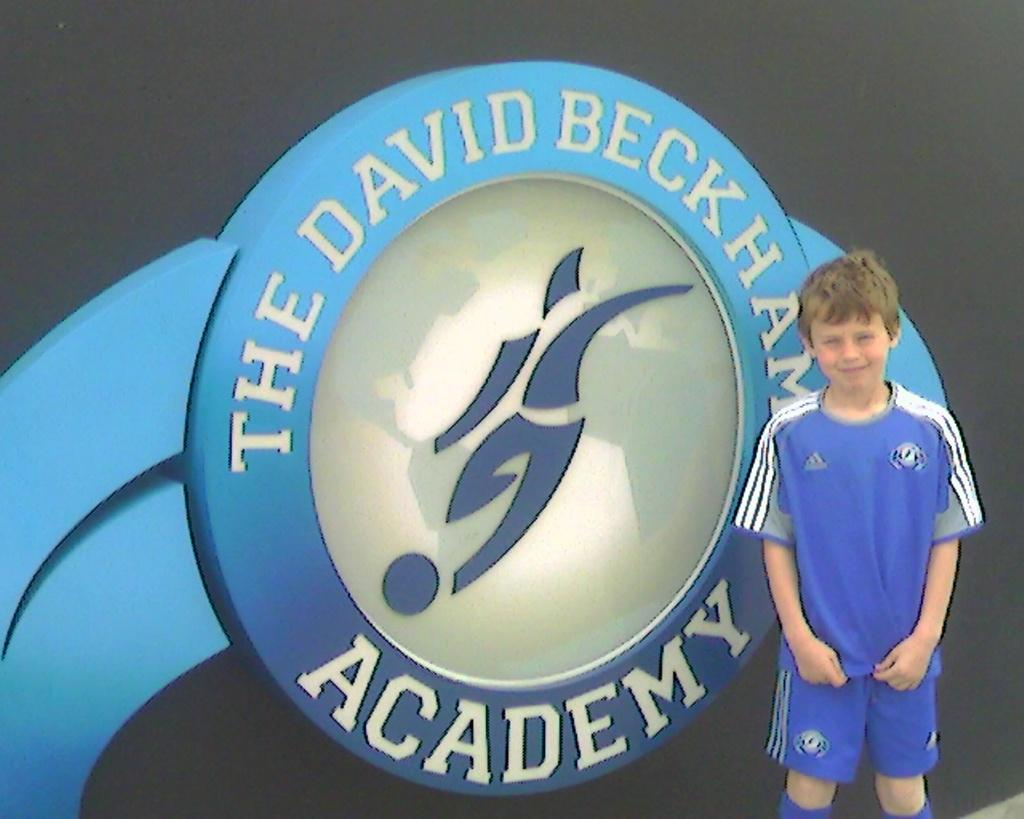<image>
Relay a brief, clear account of the picture shown. Young boy standing in front of the david beckham academy sign. 